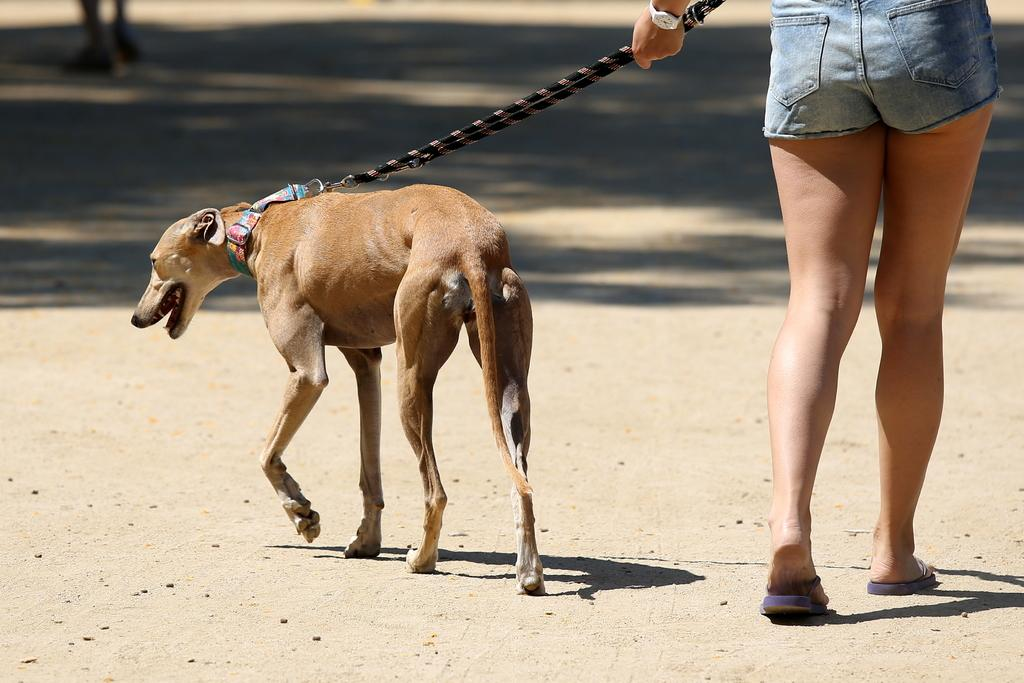Who is present in the image? There is a woman in the image. What is the woman holding? The woman is holding a dog. Can you describe the dog's appearance? The dog is brown in color. How is the dog being held? The dog is being held with a string. What is the woman and the dog doing in the image? The woman and the dog are walking. Are there any other people in the image? Yes, there is another human walking in the image. What type of robin can be seen crying in the image? There is no robin present in the image, and no one is crying. 